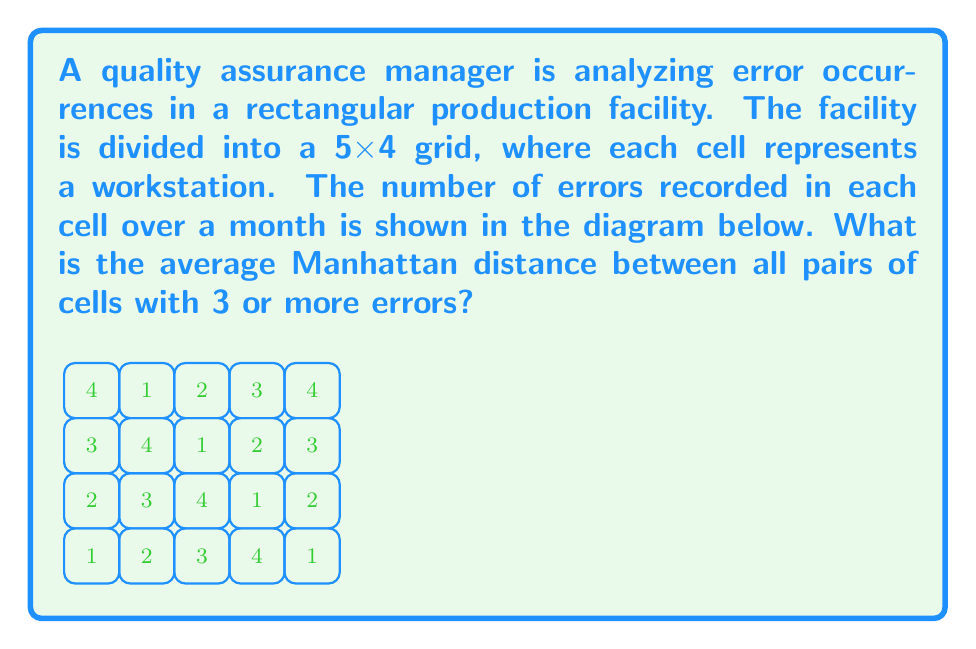Could you help me with this problem? Let's approach this step-by-step:

1) First, identify the cells with 3 or more errors:
   - (0,0), (1,1), (2,2), (3,3), (4,0)

2) Calculate the Manhattan distance between each pair of these cells:
   - Manhattan distance = |x2 - x1| + |y2 - y1|

3) Let's calculate each pair:
   - (0,0) to (1,1): |1-0| + |1-0| = 2
   - (0,0) to (2,2): |2-0| + |2-0| = 4
   - (0,0) to (3,3): |3-0| + |3-0| = 6
   - (0,0) to (4,0): |4-0| + |0-0| = 4
   - (1,1) to (2,2): |2-1| + |2-1| = 2
   - (1,1) to (3,3): |3-1| + |3-1| = 4
   - (1,1) to (4,0): |4-1| + |0-1| = 4
   - (2,2) to (3,3): |3-2| + |3-2| = 2
   - (2,2) to (4,0): |4-2| + |0-2| = 4
   - (3,3) to (4,0): |4-3| + |0-3| = 4

4) Sum up all these distances:
   2 + 4 + 6 + 4 + 2 + 4 + 4 + 2 + 4 + 4 = 36

5) Count the number of pairs:
   There are 5 cells, so there are $\binom{5}{2} = 10$ pairs

6) Calculate the average:
   Average = Total distance / Number of pairs = 36 / 10 = 3.6

Therefore, the average Manhattan distance between all pairs of cells with 3 or more errors is 3.6.
Answer: 3.6 